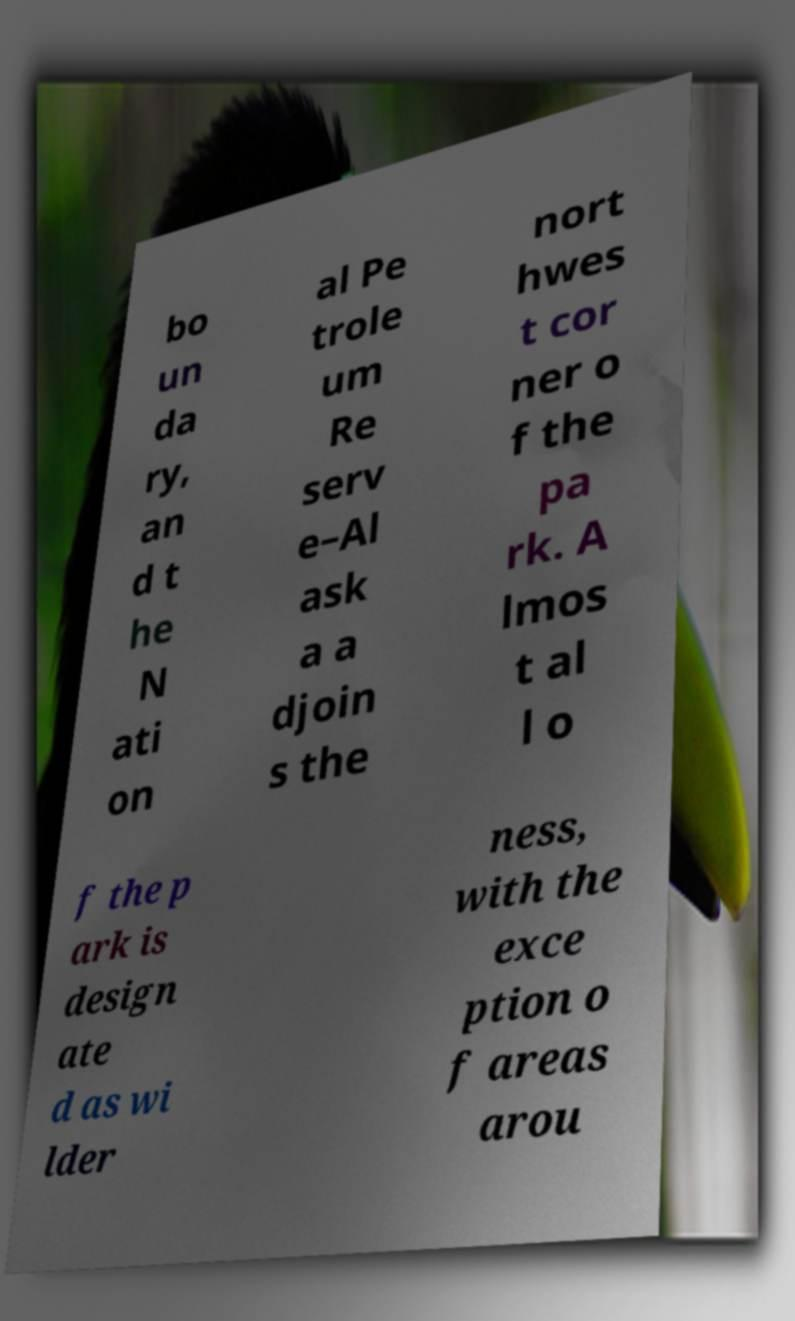Please identify and transcribe the text found in this image. bo un da ry, an d t he N ati on al Pe trole um Re serv e–Al ask a a djoin s the nort hwes t cor ner o f the pa rk. A lmos t al l o f the p ark is design ate d as wi lder ness, with the exce ption o f areas arou 